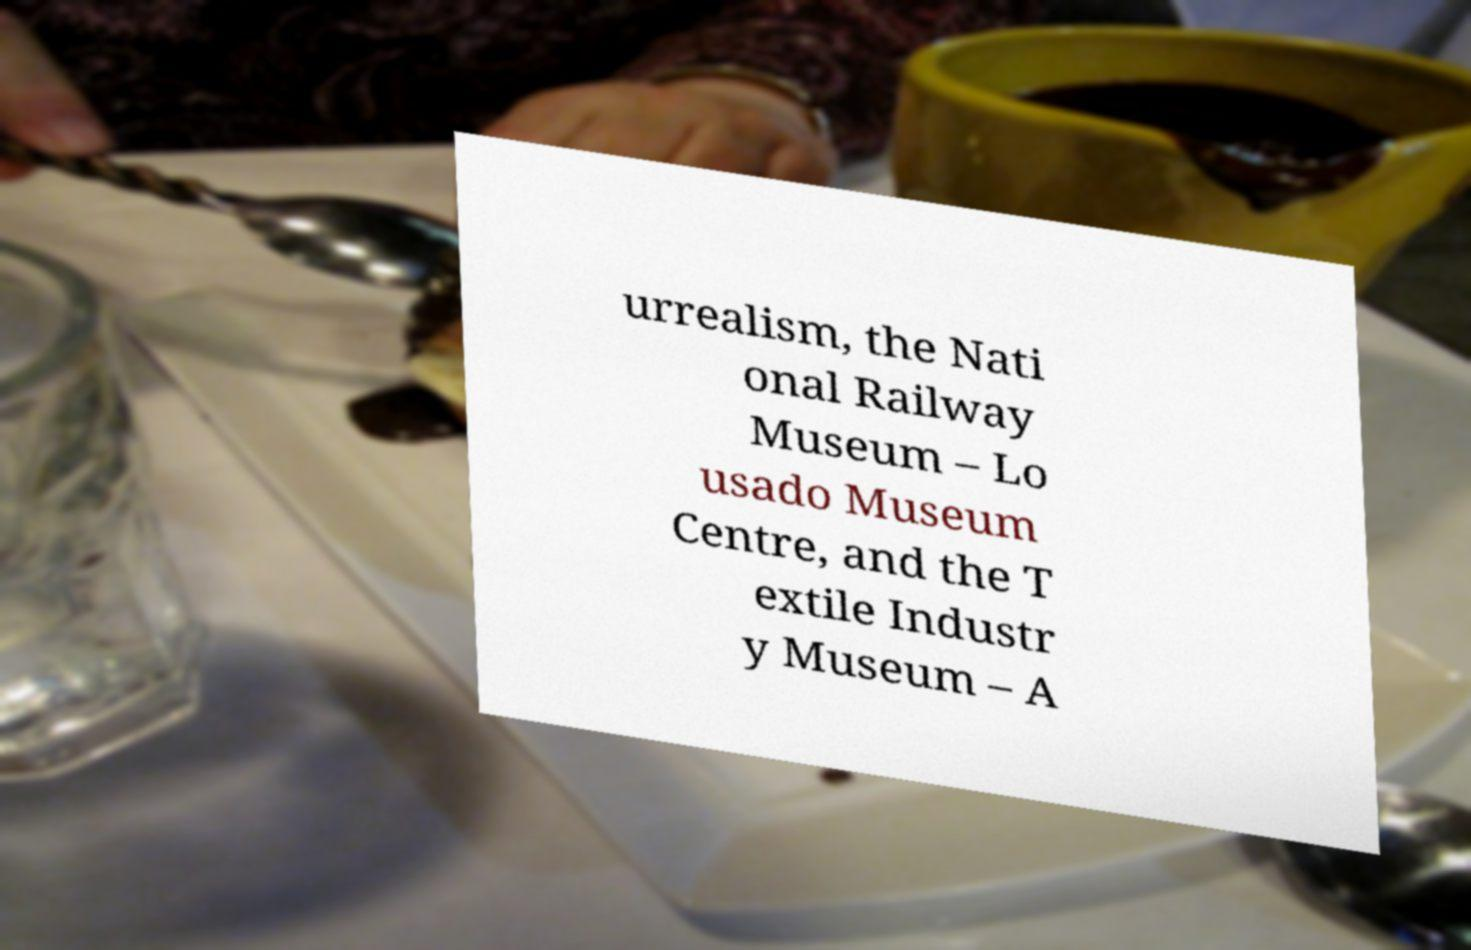Please read and relay the text visible in this image. What does it say? urrealism, the Nati onal Railway Museum – Lo usado Museum Centre, and the T extile Industr y Museum – A 